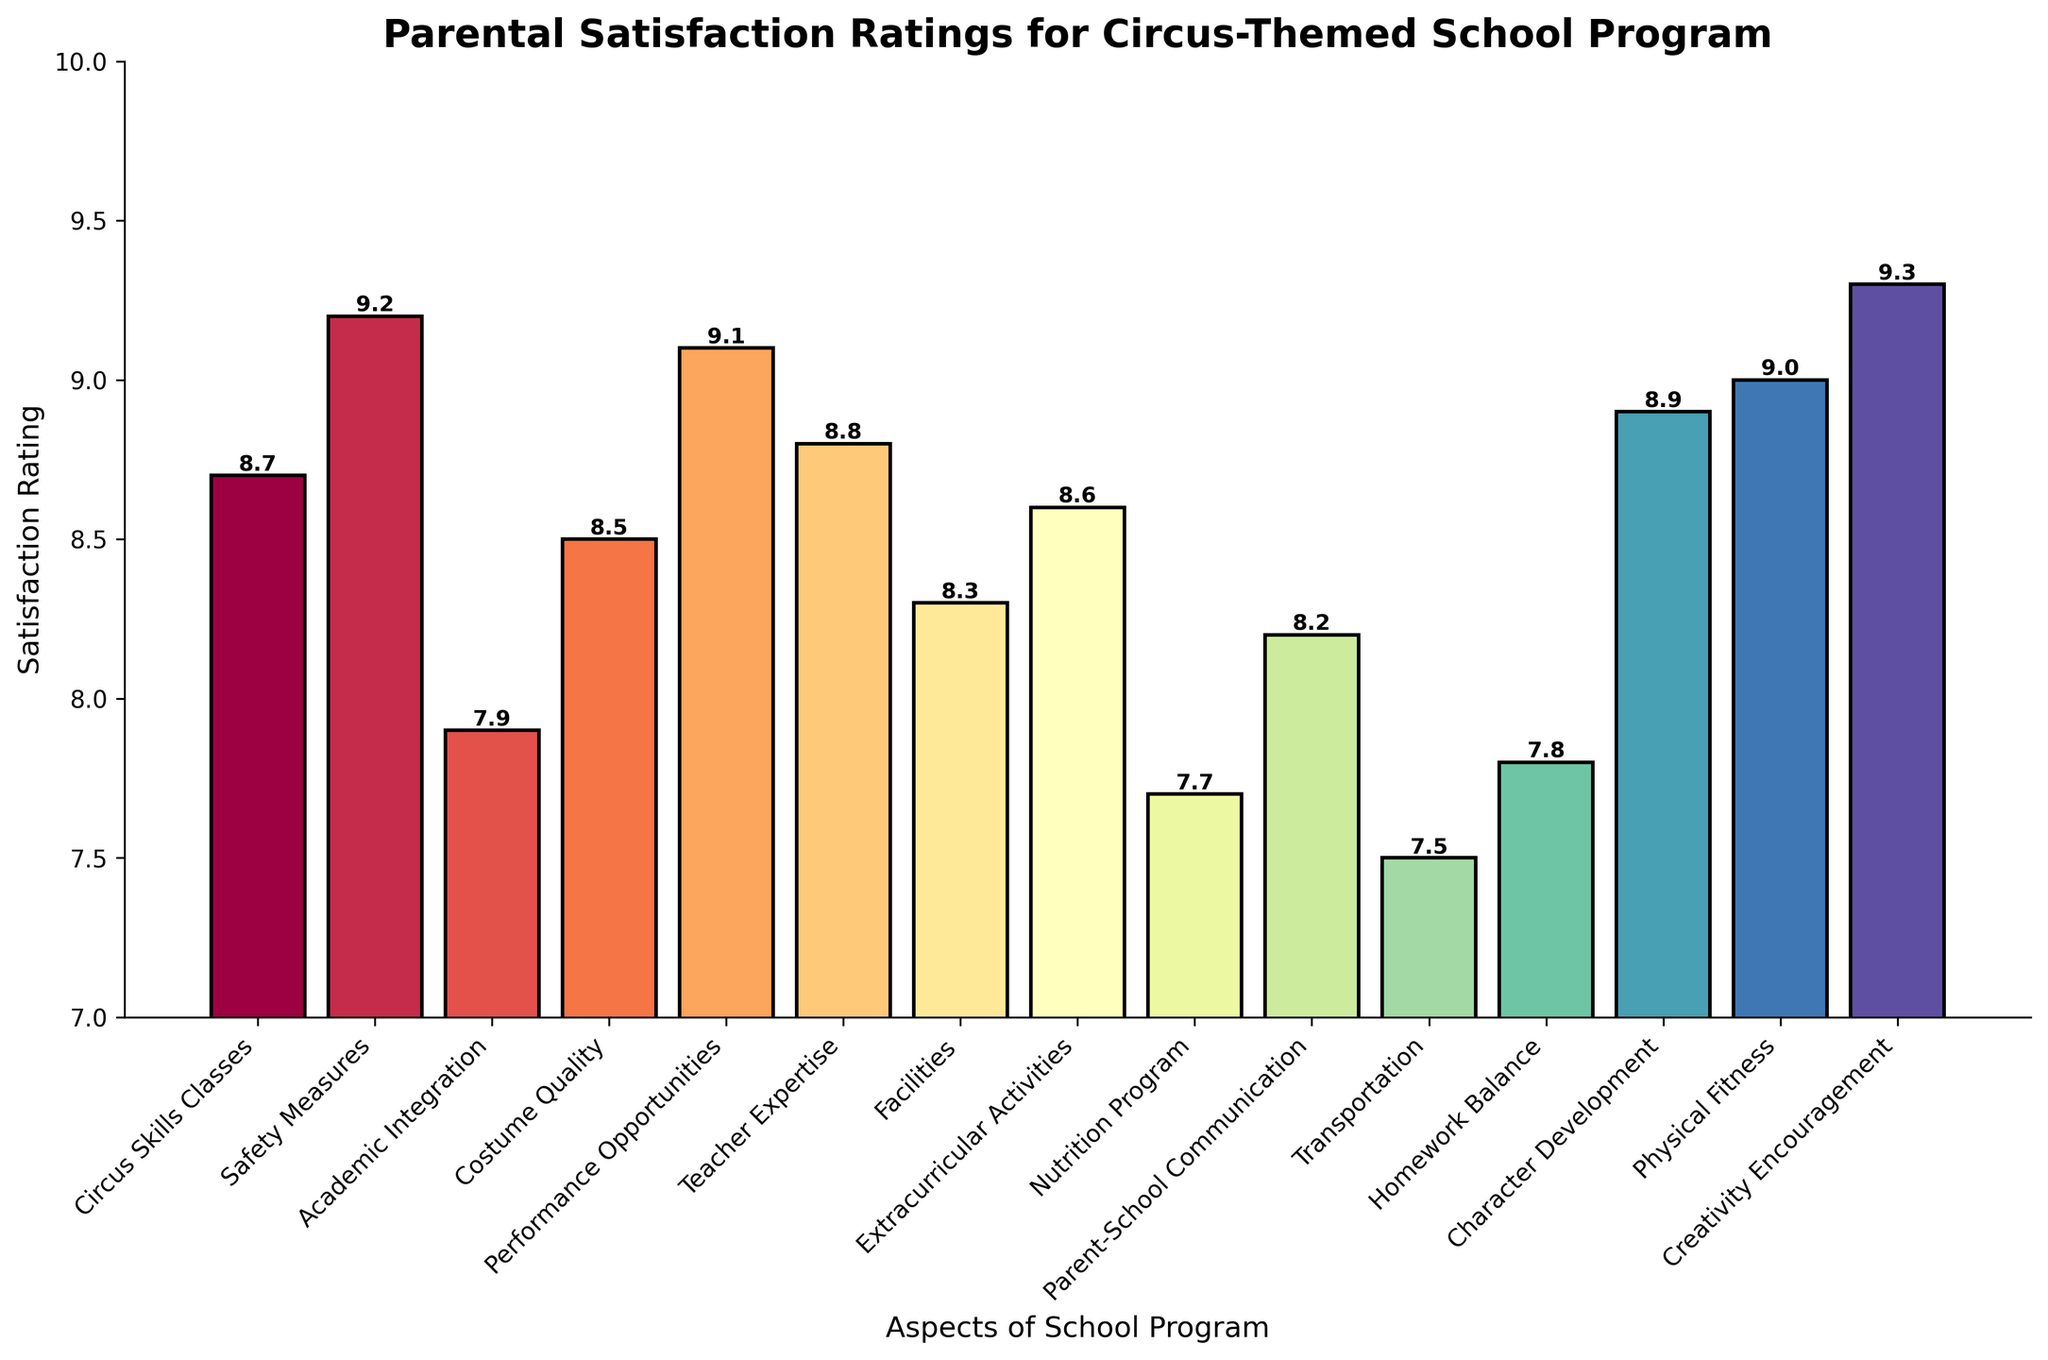What's the highest parental satisfaction rating? Look at the heights of all the bars and identify the one that is tallest. The tallest bar corresponds to "Creativity Encouragement" with a rating of 9.3.
Answer: 9.3 Which aspect has the lowest parental satisfaction rating? Look at the heights of all the bars and identify the one that is shortest. The shortest bar corresponds to "Transportation" with a rating of 7.5.
Answer: Transportation How does the satisfaction rating for "Safety Measures" compare with "Performance Opportunities"? Compare the heights of the bars for "Safety Measures" and "Performance Opportunities". "Safety Measures" has a rating of 9.2, while "Performance Opportunities" has a rating of 9.1.
Answer: Safety Measures is higher What is the average satisfaction rating for "Circus Skills Classes", "Costume Quality", and "Nutrition Program"? Sum the ratings for "Circus Skills Classes" (8.7), "Costume Quality" (8.5), and "Nutrition Program" (7.7), then divide by the number of aspects (3). (8.7 + 8.5 + 7.7) / 3 = 24.9 / 3 = 8.3
Answer: 8.3 Which aspect has a higher rating: "Teacher Expertise" or "Facilities"? Look at the heights of the bars for "Teacher Expertise" and "Facilities". "Teacher Expertise" has a rating of 8.8, while "Facilities" has a rating of 8.3.
Answer: Teacher Expertise How much higher is "Character Development" rating compared to "Homework Balance"? Identify the ratings for "Character Development" (8.9) and "Homework Balance" (7.8). Then subtract the lower rating from the higher rating. 8.9 - 7.8 = 1.1
Answer: 1.1 What is the total satisfaction rating for all listed aspects? Sum the satisfaction ratings for all aspects listed in the chart: 8.7 + 9.2 + 7.9 + 8.5 + 9.1 + 8.8 + 8.3 + 8.6 + 7.7 + 8.2 + 7.5 + 7.8 + 8.9 + 9.0 + 9.3 = 127.5
Answer: 127.5 What is the difference between the highest and lowest parental satisfaction ratings? Identify the highest rating (9.3 for "Creativity Encouragement") and the lowest rating (7.5 for "Transportation"), then subtract the lowest from the highest. 9.3 - 7.5 = 1.8
Answer: 1.8 Which aspect has the same satisfaction rating as "Teacher Expertise", according to the bar colors? Examine the bar for "Teacher Expertise" with a rating of 8.8 and find any bar with the same height and color. There is no other aspect with the same rating and color as "Teacher Expertise" (8.8).
Answer: None 